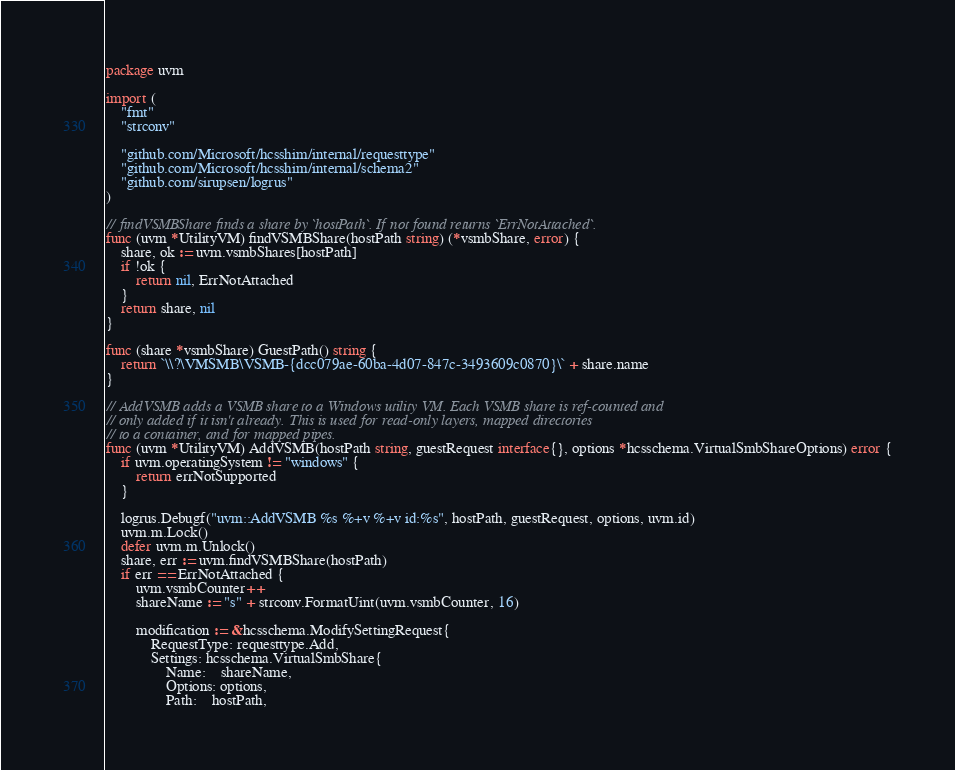<code> <loc_0><loc_0><loc_500><loc_500><_Go_>package uvm

import (
	"fmt"
	"strconv"

	"github.com/Microsoft/hcsshim/internal/requesttype"
	"github.com/Microsoft/hcsshim/internal/schema2"
	"github.com/sirupsen/logrus"
)

// findVSMBShare finds a share by `hostPath`. If not found returns `ErrNotAttached`.
func (uvm *UtilityVM) findVSMBShare(hostPath string) (*vsmbShare, error) {
	share, ok := uvm.vsmbShares[hostPath]
	if !ok {
		return nil, ErrNotAttached
	}
	return share, nil
}

func (share *vsmbShare) GuestPath() string {
	return `\\?\VMSMB\VSMB-{dcc079ae-60ba-4d07-847c-3493609c0870}\` + share.name
}

// AddVSMB adds a VSMB share to a Windows utility VM. Each VSMB share is ref-counted and
// only added if it isn't already. This is used for read-only layers, mapped directories
// to a container, and for mapped pipes.
func (uvm *UtilityVM) AddVSMB(hostPath string, guestRequest interface{}, options *hcsschema.VirtualSmbShareOptions) error {
	if uvm.operatingSystem != "windows" {
		return errNotSupported
	}

	logrus.Debugf("uvm::AddVSMB %s %+v %+v id:%s", hostPath, guestRequest, options, uvm.id)
	uvm.m.Lock()
	defer uvm.m.Unlock()
	share, err := uvm.findVSMBShare(hostPath)
	if err == ErrNotAttached {
		uvm.vsmbCounter++
		shareName := "s" + strconv.FormatUint(uvm.vsmbCounter, 16)

		modification := &hcsschema.ModifySettingRequest{
			RequestType: requesttype.Add,
			Settings: hcsschema.VirtualSmbShare{
				Name:    shareName,
				Options: options,
				Path:    hostPath,</code> 